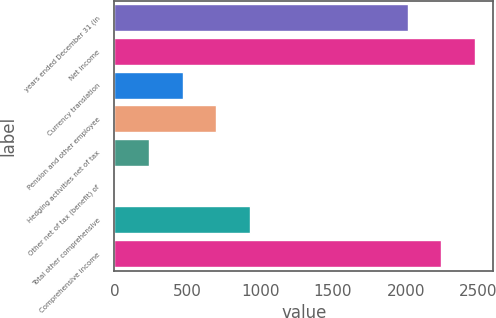Convert chart to OTSL. <chart><loc_0><loc_0><loc_500><loc_500><bar_chart><fcel>years ended December 31 (in<fcel>Net income<fcel>Currency translation<fcel>Pension and other employee<fcel>Hedging activities net of tax<fcel>Other net of tax (benefit) of<fcel>Total other comprehensive<fcel>Comprehensive income<nl><fcel>2012<fcel>2476.6<fcel>467.6<fcel>699.9<fcel>235.3<fcel>3<fcel>932.2<fcel>2244.3<nl></chart> 